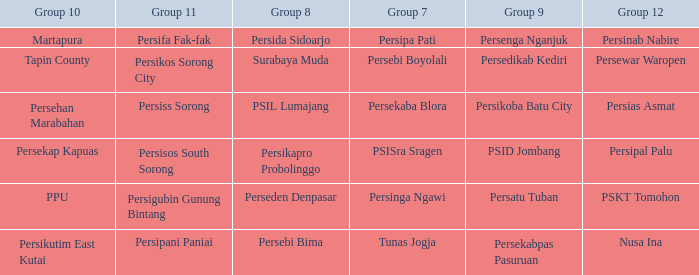Nusa Ina only played once while group 7 played. 1.0. 